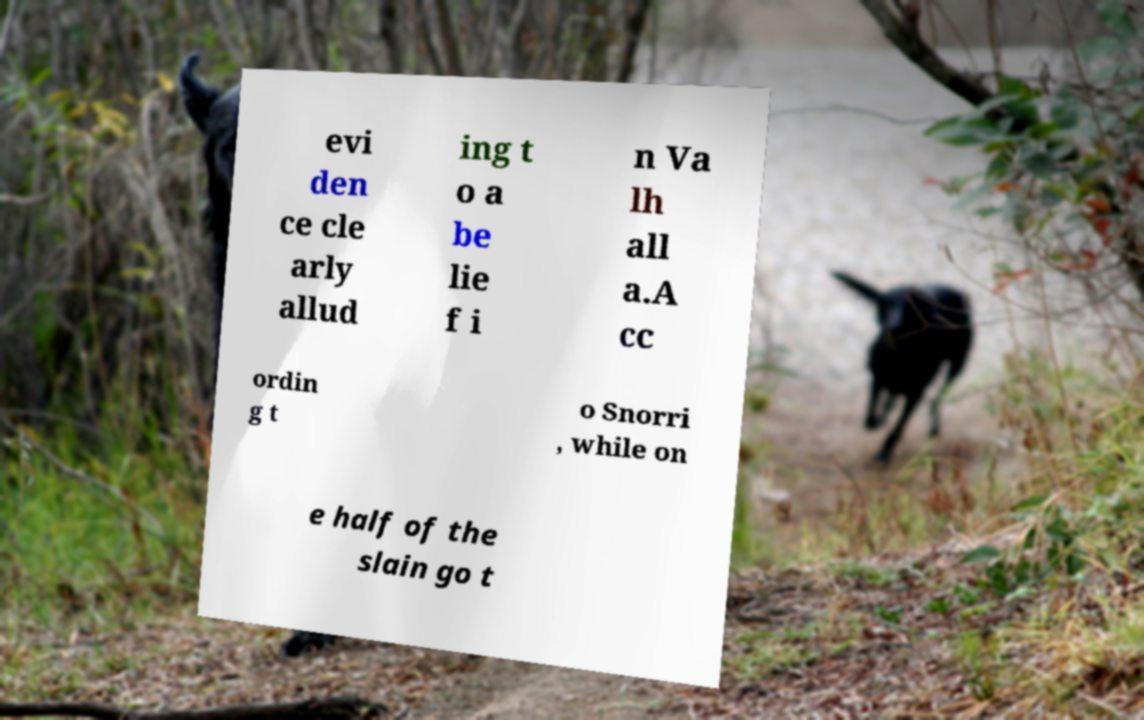Can you accurately transcribe the text from the provided image for me? evi den ce cle arly allud ing t o a be lie f i n Va lh all a.A cc ordin g t o Snorri , while on e half of the slain go t 